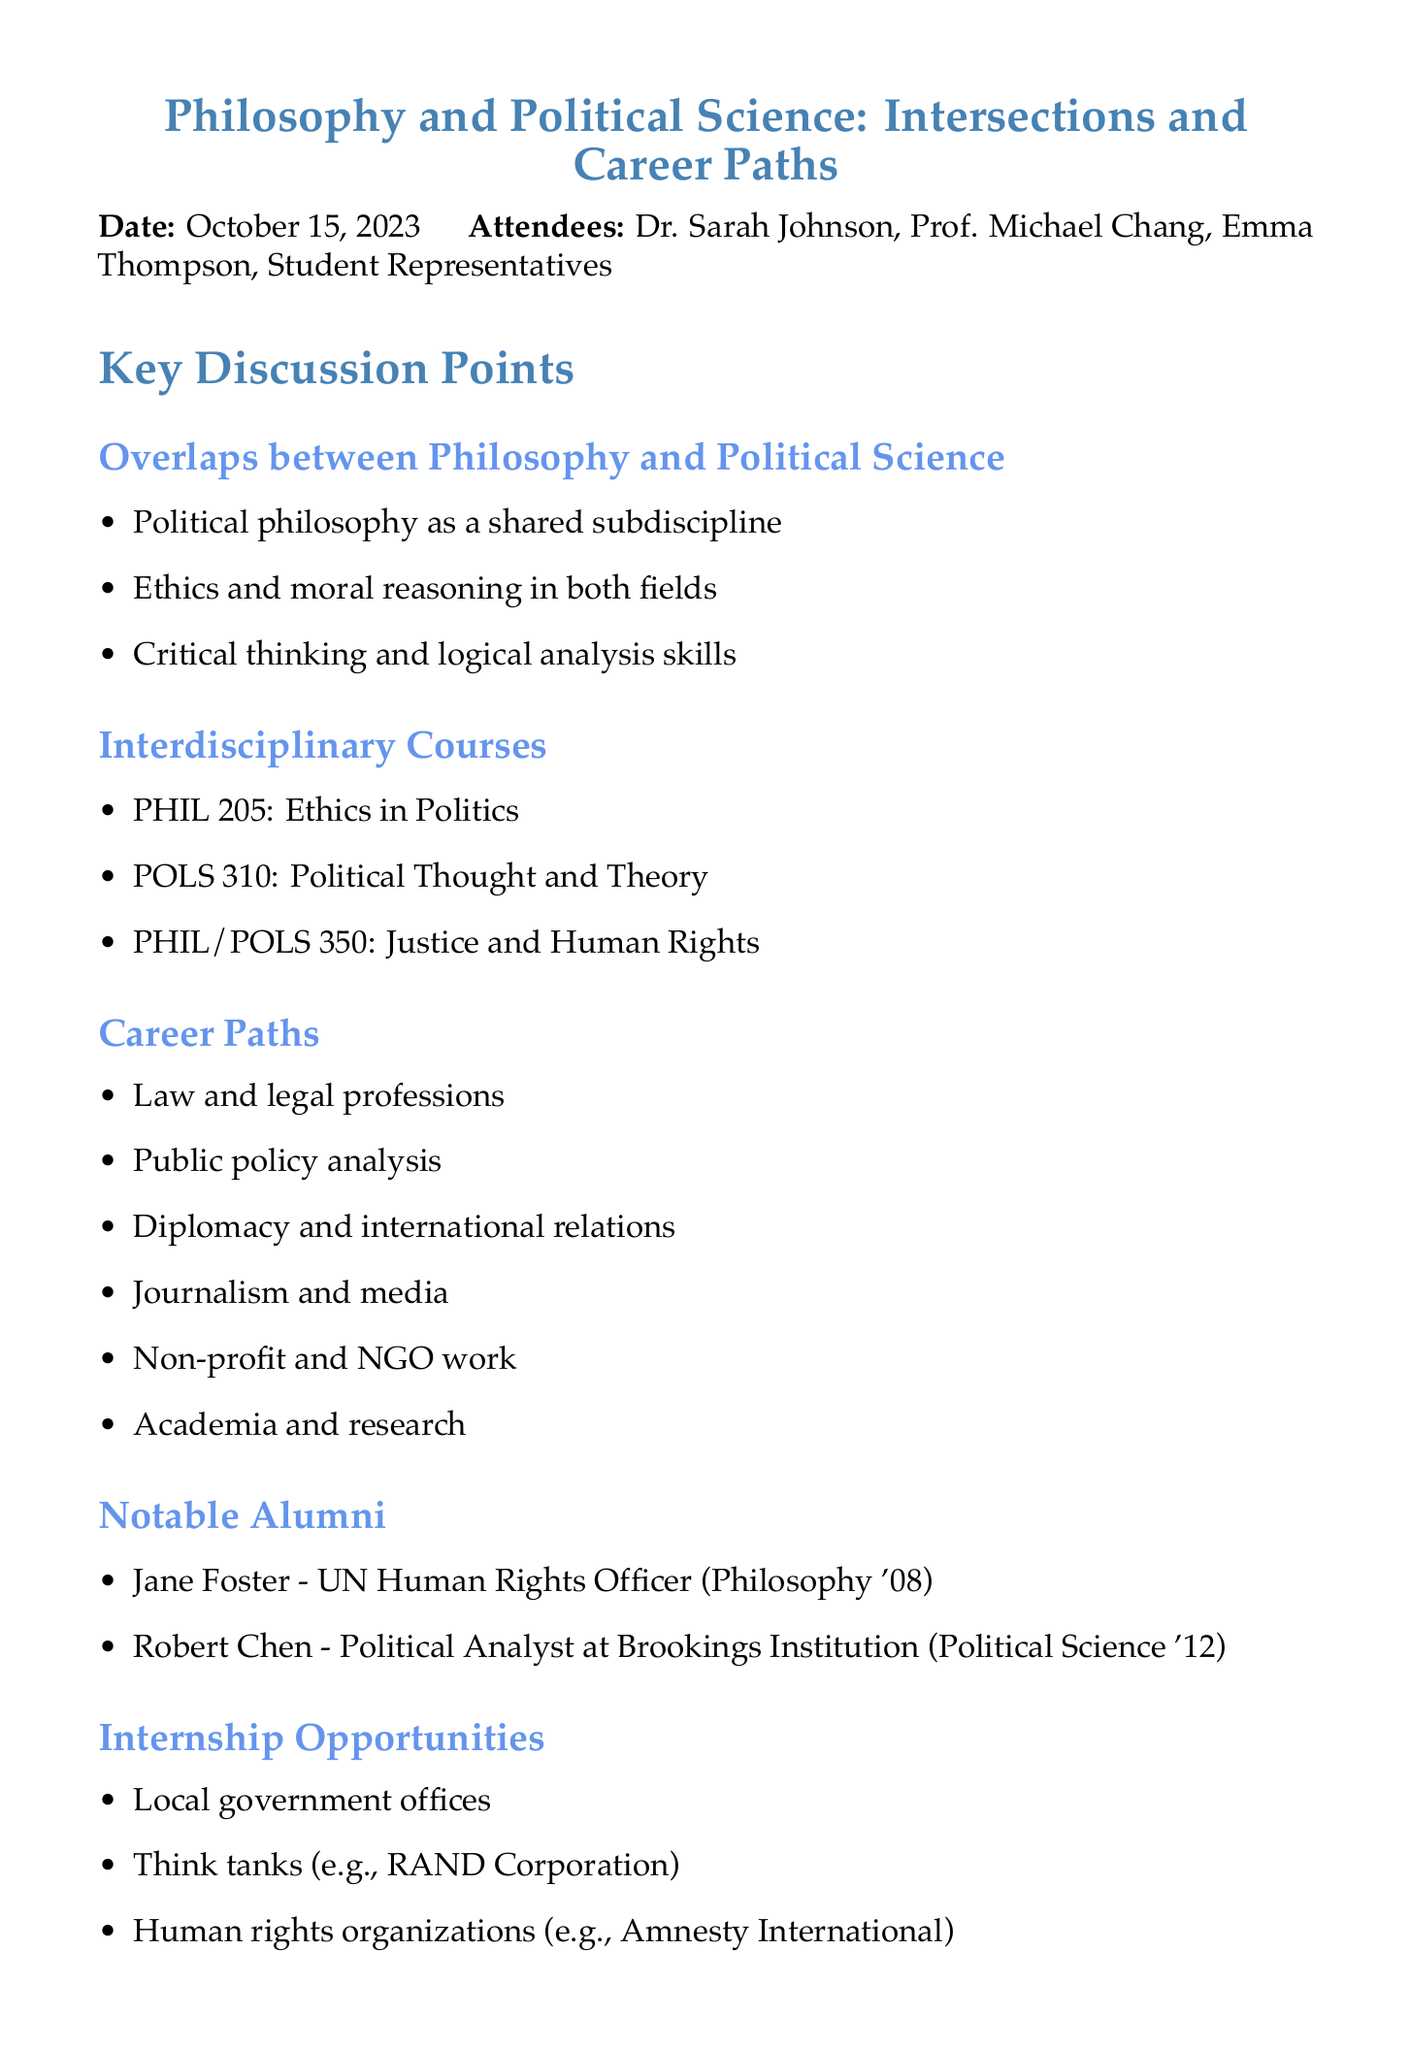What is the date of the meeting? The date of the meeting is explicitly stated in the document.
Answer: October 15, 2023 Who is the chair of the Philosophy Department? The document lists the attendees along with their roles.
Answer: Dr. Sarah Johnson What are the three key overlaps between Philosophy and Political Science? The key points under the overlaps section list the main intersections between the two fields.
Answer: Political philosophy, Ethics and moral reasoning, Critical thinking and logical analysis skills Name an interdisciplinary course mentioned in the document. The document provides examples of interdisciplinary courses specifically linking the two fields.
Answer: PHIL 205: Ethics in Politics What is one potential career path for Philosophy or Political Science majors? The document outlines several career options for graduates in these fields.
Answer: Law and legal professions Which notable alumni is mentioned as a UN Human Rights Officer? The document lists notable alumni and identifies their accomplishments.
Answer: Jane Foster How many action items are listed at the end of the document? The action items section specifies the follow-up tasks discussed in the meeting.
Answer: Three What type of graduate school program is suggested for both majors? The document outlines considerations for further education paths relevant to the two disciplines.
Answer: Joint PhD programs in Philosophy and Political Science 